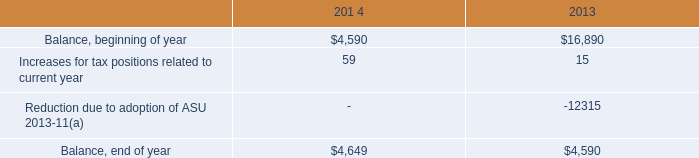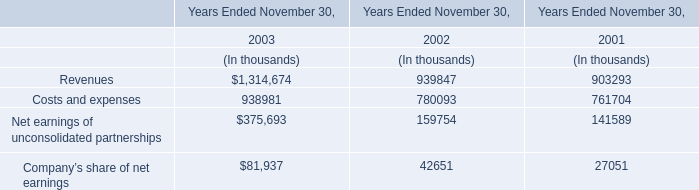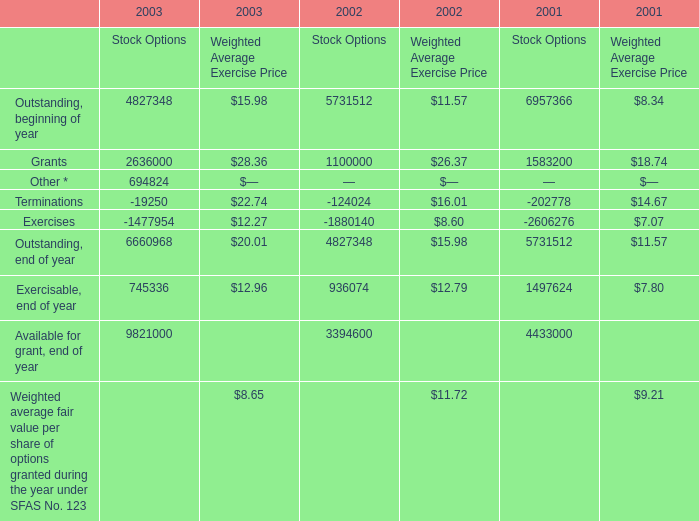What is the sum of the Outstanding, end of year for Stock Options in the year where Outstanding, beginning of year for Stock Options is greater than 6000000 ? 
Answer: 5731512. 